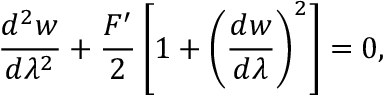<formula> <loc_0><loc_0><loc_500><loc_500>\frac { d ^ { 2 } w } { d \lambda ^ { 2 } } + \frac { F ^ { \prime } } { 2 } \left [ 1 + \left ( \frac { d w } { d \lambda } \right ) ^ { 2 } \right ] = 0 ,</formula> 